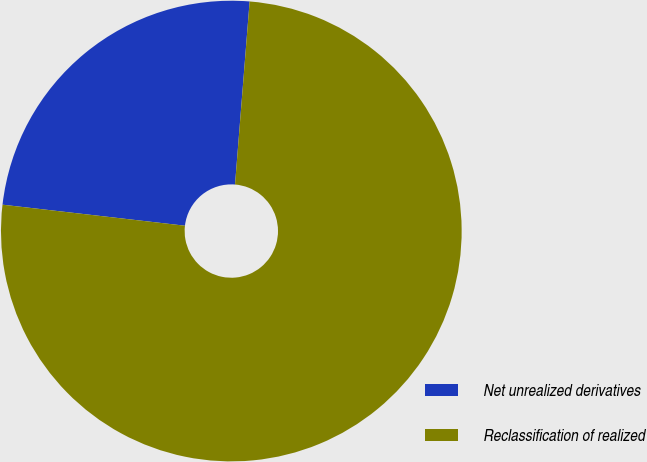Convert chart to OTSL. <chart><loc_0><loc_0><loc_500><loc_500><pie_chart><fcel>Net unrealized derivatives<fcel>Reclassification of realized<nl><fcel>24.44%<fcel>75.56%<nl></chart> 